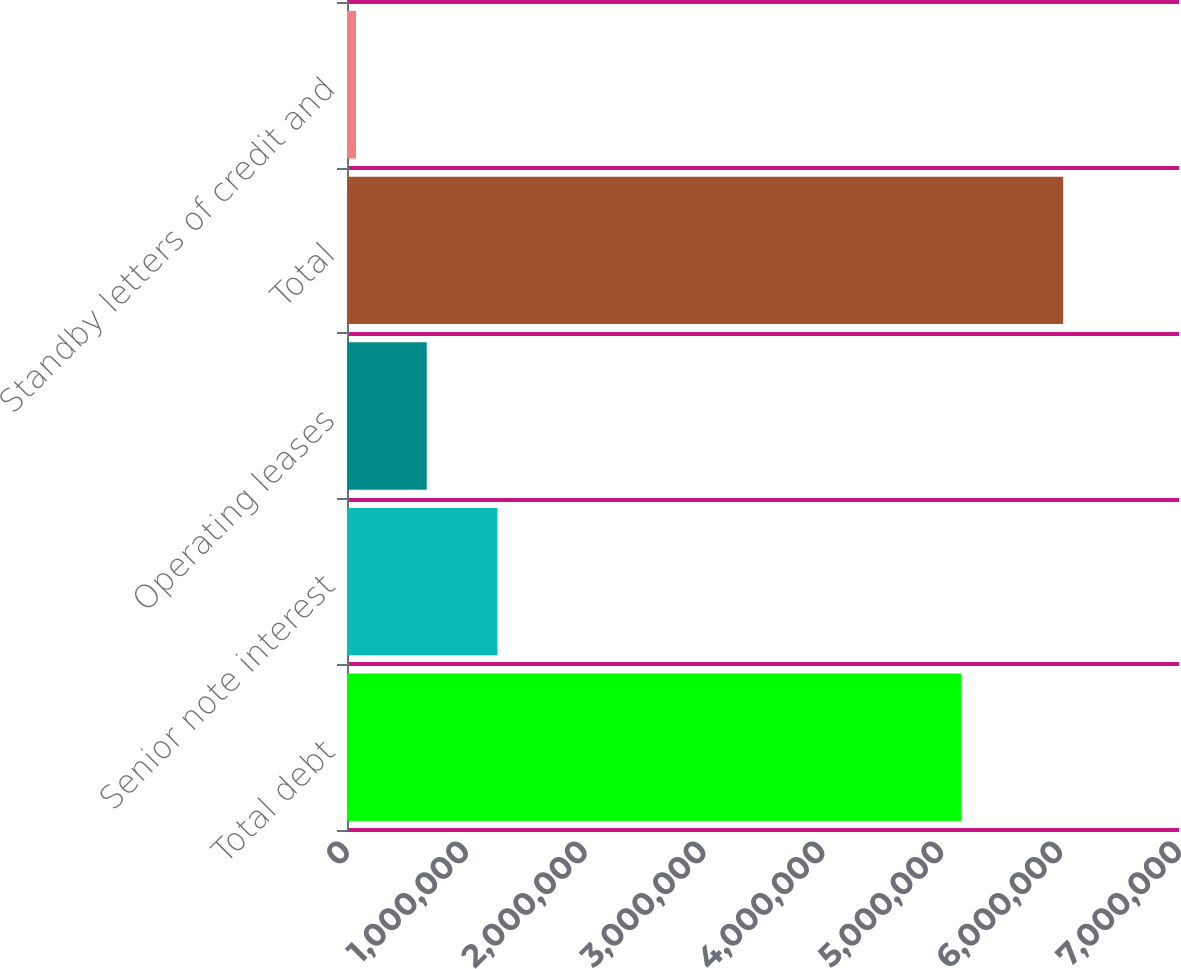<chart> <loc_0><loc_0><loc_500><loc_500><bar_chart><fcel>Total debt<fcel>Senior note interest<fcel>Operating leases<fcel>Total<fcel>Standby letters of credit and<nl><fcel>5.17001e+06<fcel>1.26574e+06<fcel>670817<fcel>6.02509e+06<fcel>75898<nl></chart> 